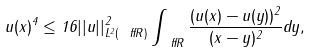<formula> <loc_0><loc_0><loc_500><loc_500>u ( x ) ^ { 4 } \leq 1 6 | | u | | ^ { 2 } _ { L ^ { 2 } ( \ f f { R } ) } \int _ { \ f f { R } } \frac { ( u ( x ) - u ( y ) ) ^ { 2 } } { ( x - y ) ^ { 2 } } d y ,</formula> 